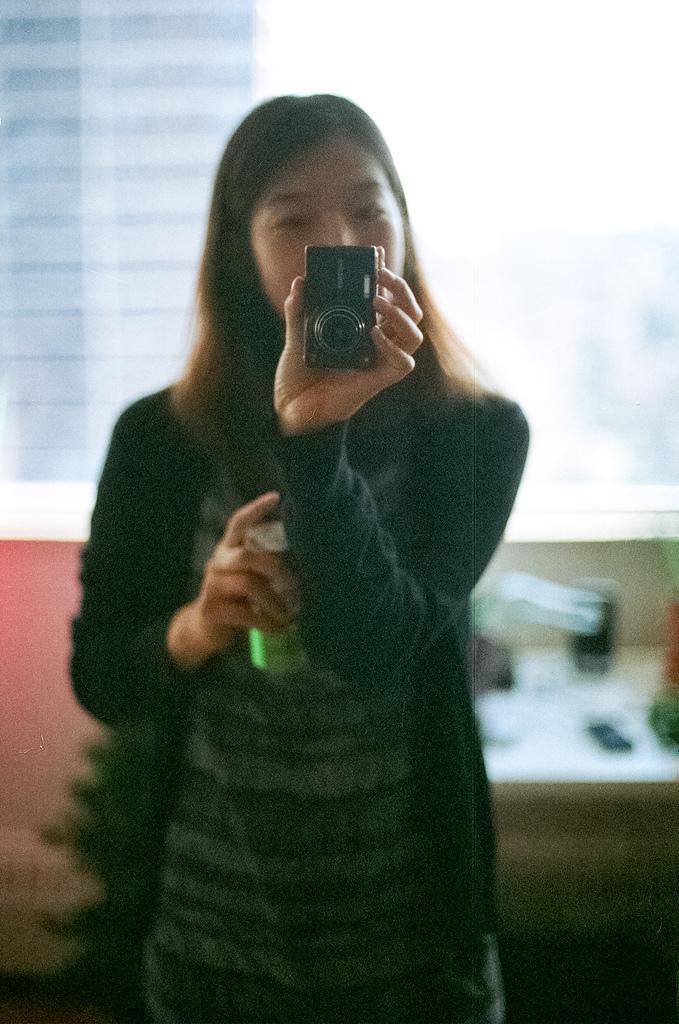In one or two sentences, can you explain what this image depicts? In this image I see a woman who is holding a camera and a can in her hands. 